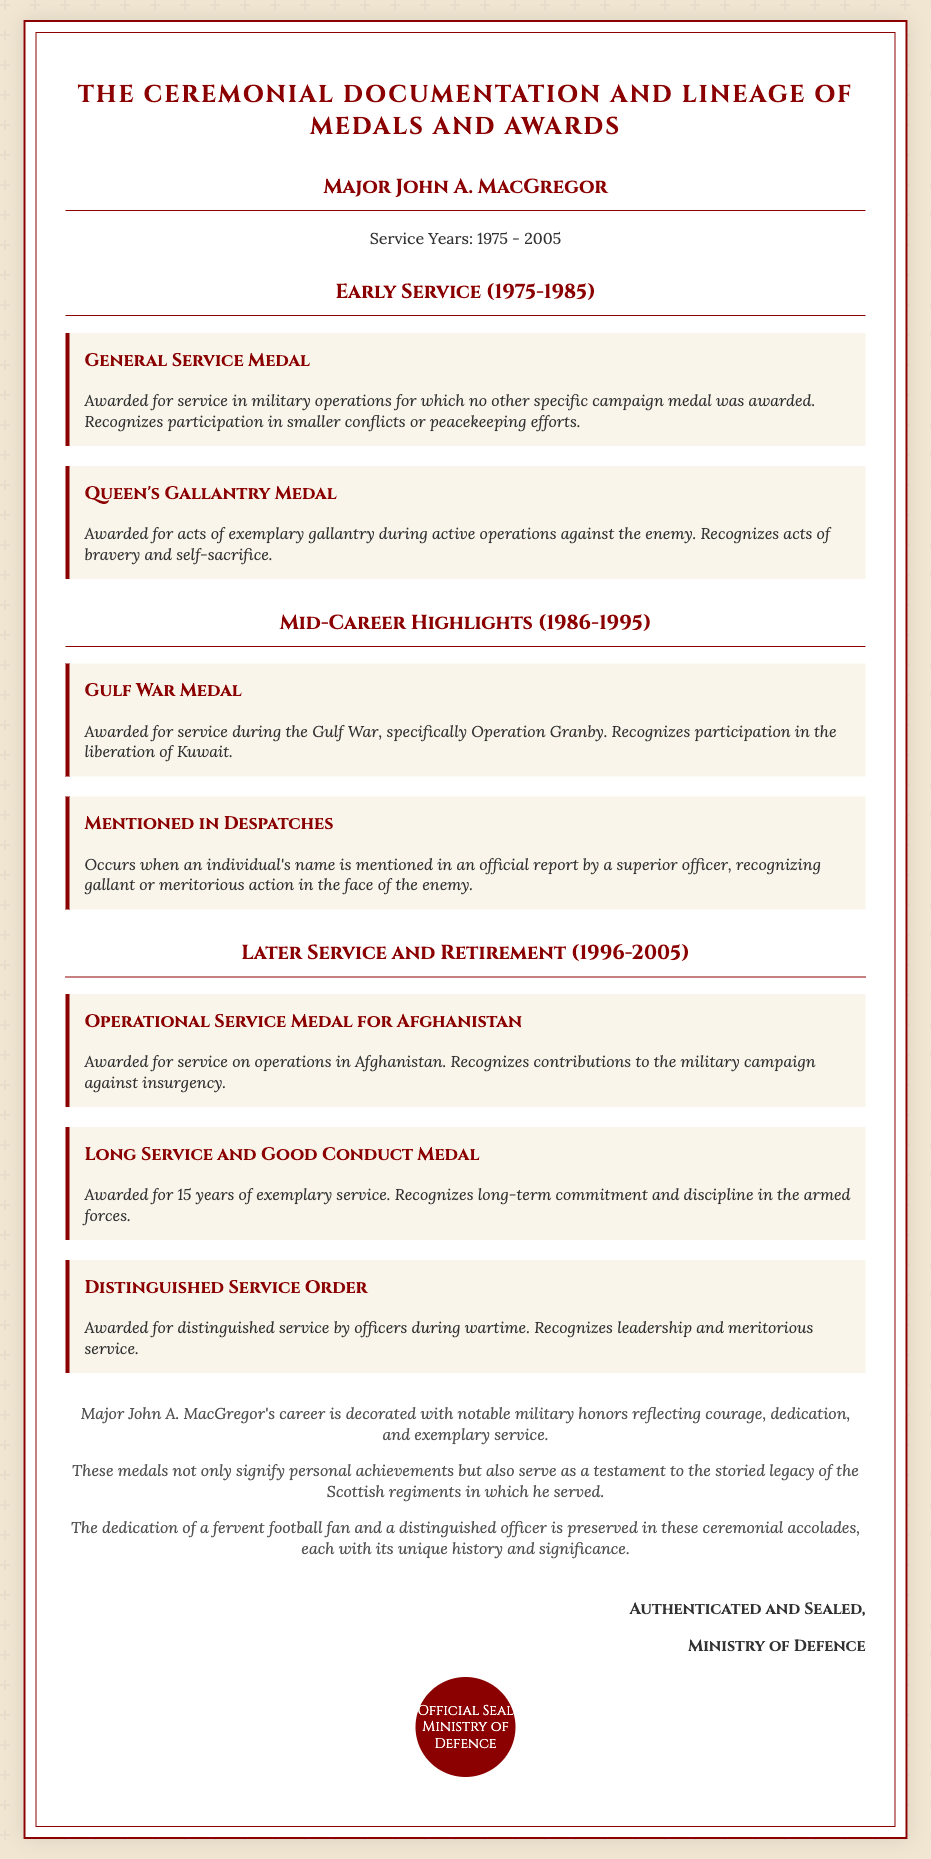What is the name of the officer? The officer's name is highlighted prominently at the top of the document as the subject of the deed.
Answer: Major John A. MacGregor What years did Major MacGregor serve? The document explicitly states the service years of the officer at the beginning.
Answer: 1975 - 2005 How many medals were awarded during early service? The early service period (1975-1985) lists two distinct medals within the corresponding section.
Answer: 2 What medal is awarded for acts of exemplary gallantry? The medal awarded for exemplary gallantry is specifically described in the early service section of the document.
Answer: Queen's Gallantry Medal Which medal recognizes contributions to the military campaign against insurgency? The document defines this medal in the "Later Service and Retirement" section, specifically mentioning its significance.
Answer: Operational Service Medal for Afghanistan What is the significance of the Long Service and Good Conduct Medal? The document mentions the reason for this medal within the context of the officer's career accolades.
Answer: 15 years of exemplary service What is mentioned in the concluding remarks about Major MacGregor's achievements? The concluding remarks summarize the officer's career highlights and their reflection on personal dedication.
Answer: Notable military honors How does the document authenticate its details? The document contains an authentication section that specifies which entity provided the verification of the deed.
Answer: Ministry of Defence 